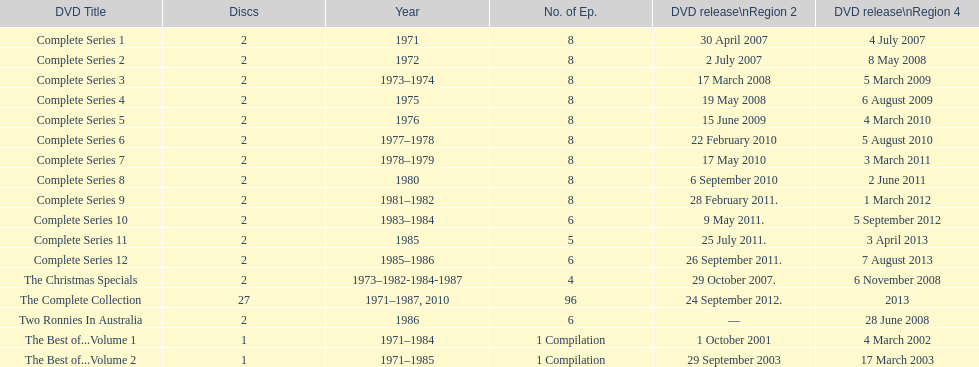Parse the full table. {'header': ['DVD Title', 'Discs', 'Year', 'No. of Ep.', 'DVD release\\nRegion 2', 'DVD release\\nRegion 4'], 'rows': [['Complete Series 1', '2', '1971', '8', '30 April 2007', '4 July 2007'], ['Complete Series 2', '2', '1972', '8', '2 July 2007', '8 May 2008'], ['Complete Series 3', '2', '1973–1974', '8', '17 March 2008', '5 March 2009'], ['Complete Series 4', '2', '1975', '8', '19 May 2008', '6 August 2009'], ['Complete Series 5', '2', '1976', '8', '15 June 2009', '4 March 2010'], ['Complete Series 6', '2', '1977–1978', '8', '22 February 2010', '5 August 2010'], ['Complete Series 7', '2', '1978–1979', '8', '17 May 2010', '3 March 2011'], ['Complete Series 8', '2', '1980', '8', '6 September 2010', '2 June 2011'], ['Complete Series 9', '2', '1981–1982', '8', '28 February 2011.', '1 March 2012'], ['Complete Series 10', '2', '1983–1984', '6', '9 May 2011.', '5 September 2012'], ['Complete Series 11', '2', '1985', '5', '25 July 2011.', '3 April 2013'], ['Complete Series 12', '2', '1985–1986', '6', '26 September 2011.', '7 August 2013'], ['The Christmas Specials', '2', '1973–1982-1984-1987', '4', '29 October 2007.', '6 November 2008'], ['The Complete Collection', '27', '1971–1987, 2010', '96', '24 September 2012.', '2013'], ['Two Ronnies In Australia', '2', '1986', '6', '—', '28 June 2008'], ['The Best of...Volume 1', '1', '1971–1984', '1 Compilation', '1 October 2001', '4 March 2002'], ['The Best of...Volume 2', '1', '1971–1985', '1 Compilation', '29 September 2003', '17 March 2003']]} What was the total number of seasons for "the two ronnies" television show? 12. 